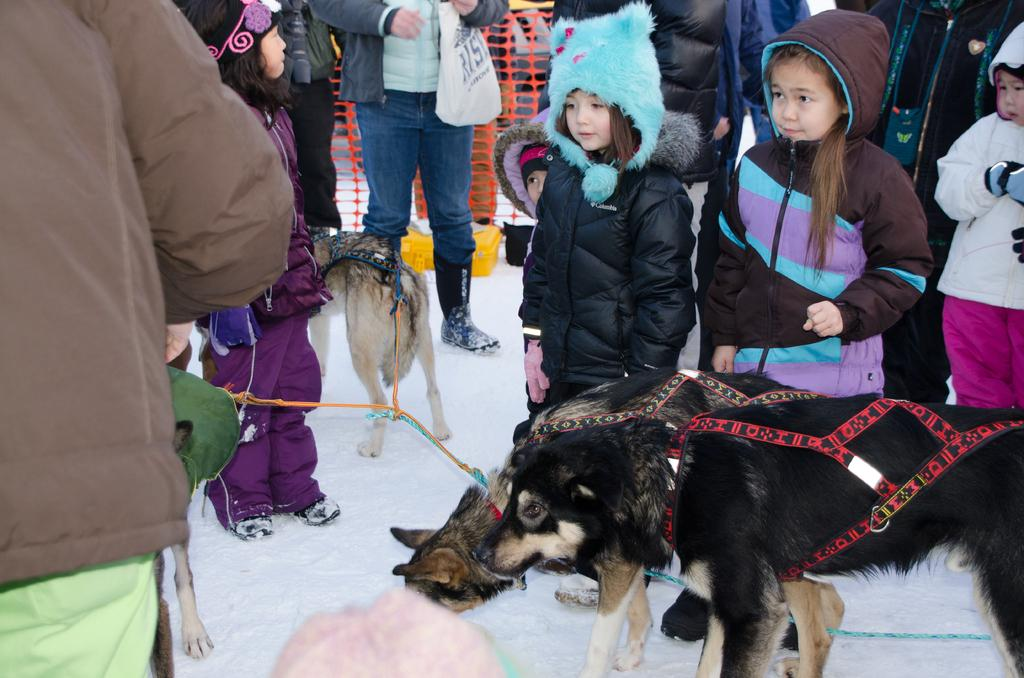Where was the image taken? The image was taken outside. How many people are in the image? There are many people in the image. Are there any children in the image? Yes, there are kids in the image. Are there any animals in the image? Yes, there are dogs in the image. What is visible at the bottom of the image? There is ice in the bottom of the image. What type of clothing are people wearing in the image? People are wearing sweaters in the image. What type of pancake is being served on the bridge in the image? There is no pancake or bridge present in the image. What color is the curtain hanging in the background of the image? There is no curtain visible in the image. 